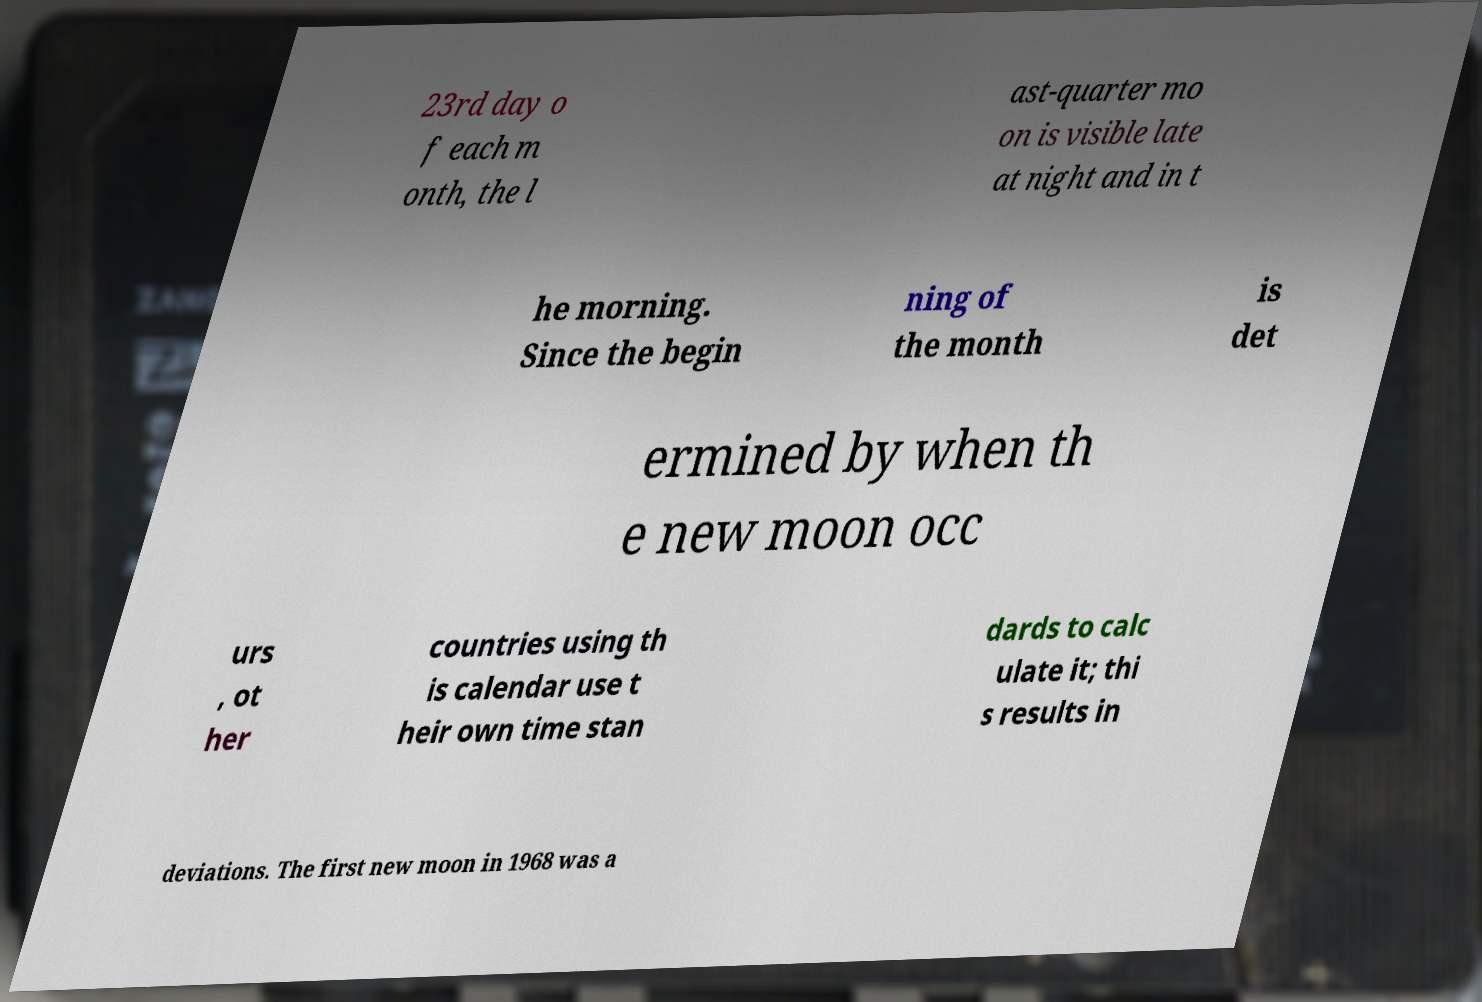For documentation purposes, I need the text within this image transcribed. Could you provide that? 23rd day o f each m onth, the l ast-quarter mo on is visible late at night and in t he morning. Since the begin ning of the month is det ermined by when th e new moon occ urs , ot her countries using th is calendar use t heir own time stan dards to calc ulate it; thi s results in deviations. The first new moon in 1968 was a 